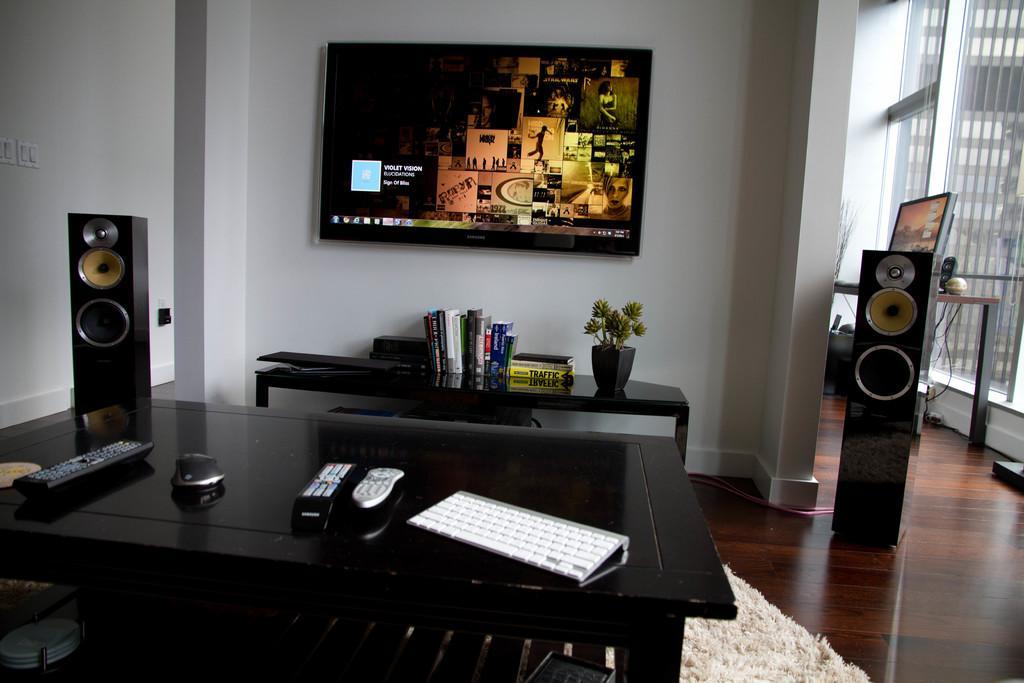Please provide a concise description of this image. The picture is taken inside the room in which there is a tv attached to the wall under which there is a table on which there is flower pot and books. There is a table in the middle which has keyboard,remote,mouse and speaker on it. There is a mat on the floor. 